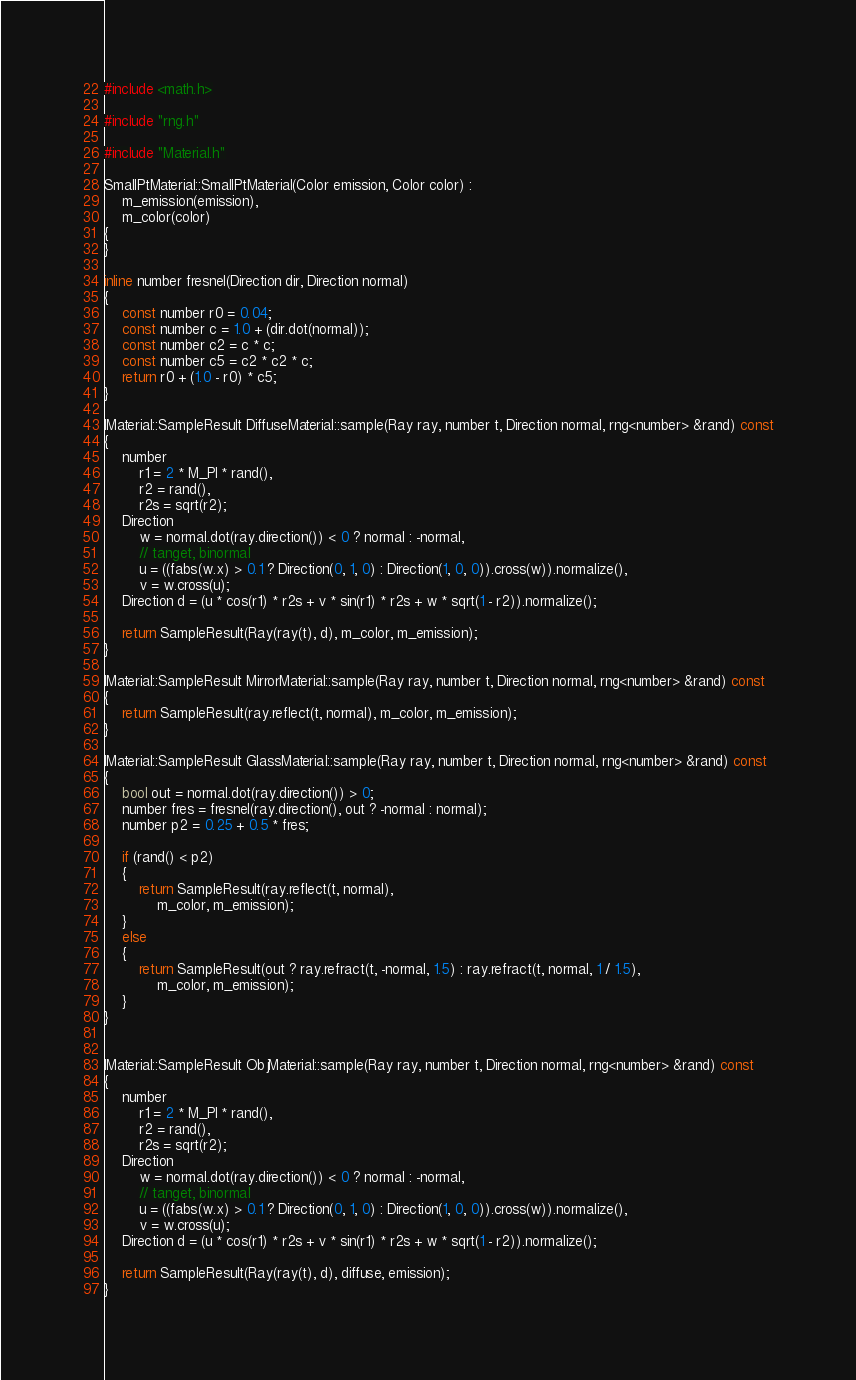<code> <loc_0><loc_0><loc_500><loc_500><_C++_>
#include <math.h>

#include "rng.h"

#include "Material.h"

SmallPtMaterial::SmallPtMaterial(Color emission, Color color) :
    m_emission(emission),
    m_color(color)
{
}

inline number fresnel(Direction dir, Direction normal)
{
    const number r0 = 0.04;
    const number c = 1.0 + (dir.dot(normal));
    const number c2 = c * c;
    const number c5 = c2 * c2 * c;
    return r0 + (1.0 - r0) * c5;
}

IMaterial::SampleResult DiffuseMaterial::sample(Ray ray, number t, Direction normal, rng<number> &rand) const
{
    number
        r1 = 2 * M_PI * rand(),
        r2 = rand(),
        r2s = sqrt(r2);
    Direction
        w = normal.dot(ray.direction()) < 0 ? normal : -normal,
        // tanget, binormal
        u = ((fabs(w.x) > 0.1 ? Direction(0, 1, 0) : Direction(1, 0, 0)).cross(w)).normalize(),
        v = w.cross(u);
    Direction d = (u * cos(r1) * r2s + v * sin(r1) * r2s + w * sqrt(1 - r2)).normalize();

    return SampleResult(Ray(ray(t), d), m_color, m_emission);
}

IMaterial::SampleResult MirrorMaterial::sample(Ray ray, number t, Direction normal, rng<number> &rand) const
{
    return SampleResult(ray.reflect(t, normal), m_color, m_emission);
}

IMaterial::SampleResult GlassMaterial::sample(Ray ray, number t, Direction normal, rng<number> &rand) const
{
    bool out = normal.dot(ray.direction()) > 0;
    number fres = fresnel(ray.direction(), out ? -normal : normal);
    number p2 = 0.25 + 0.5 * fres;

    if (rand() < p2)
    {
        return SampleResult(ray.reflect(t, normal),
            m_color, m_emission);
    }
    else
    {
        return SampleResult(out ? ray.refract(t, -normal, 1.5) : ray.refract(t, normal, 1 / 1.5),
            m_color, m_emission);
    }
}


IMaterial::SampleResult ObjMaterial::sample(Ray ray, number t, Direction normal, rng<number> &rand) const
{
    number
        r1 = 2 * M_PI * rand(),
        r2 = rand(),
        r2s = sqrt(r2);
    Direction
        w = normal.dot(ray.direction()) < 0 ? normal : -normal,
        // tanget, binormal
        u = ((fabs(w.x) > 0.1 ? Direction(0, 1, 0) : Direction(1, 0, 0)).cross(w)).normalize(),
        v = w.cross(u);
    Direction d = (u * cos(r1) * r2s + v * sin(r1) * r2s + w * sqrt(1 - r2)).normalize();

    return SampleResult(Ray(ray(t), d), diffuse, emission);
}</code> 